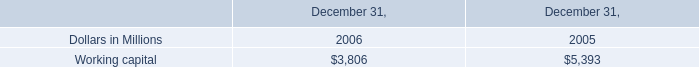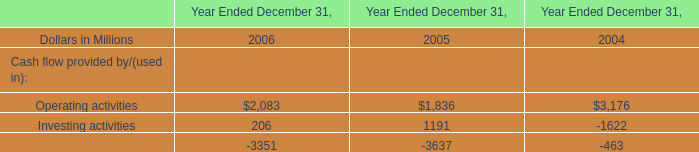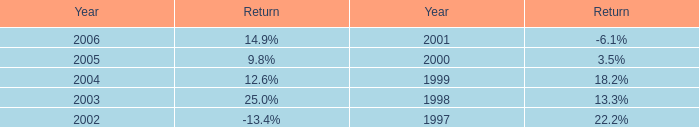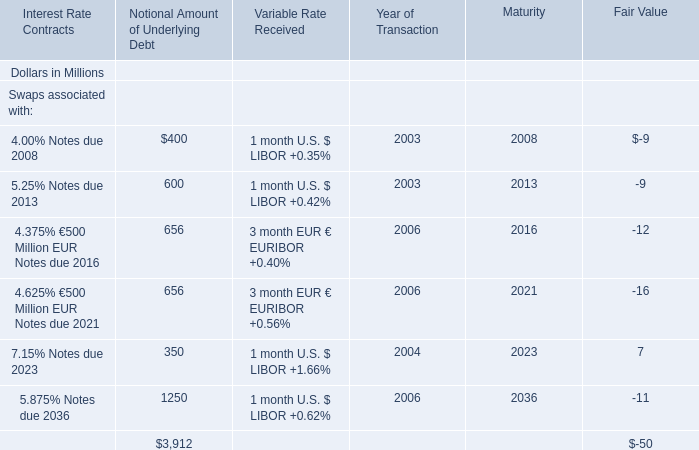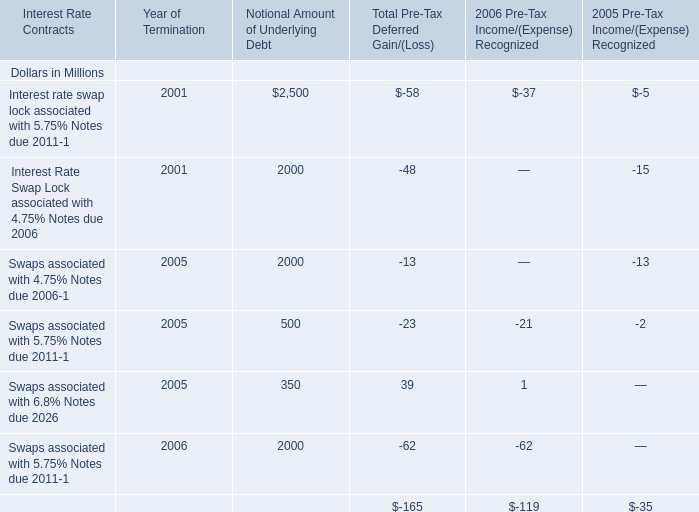What is the total amount of Working capital of December 31, 2005, and Investing activities of Year Ended December 31, 2004 ? 
Computations: (5393.0 + 1622.0)
Answer: 7015.0. 